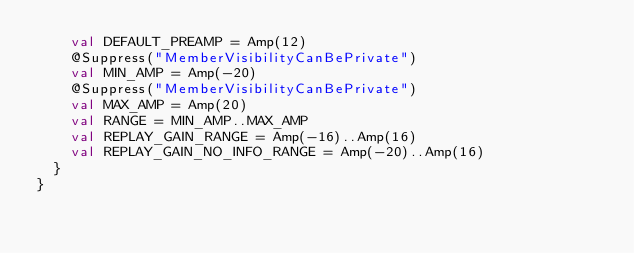<code> <loc_0><loc_0><loc_500><loc_500><_Kotlin_>    val DEFAULT_PREAMP = Amp(12)
    @Suppress("MemberVisibilityCanBePrivate")
    val MIN_AMP = Amp(-20)
    @Suppress("MemberVisibilityCanBePrivate")
    val MAX_AMP = Amp(20)
    val RANGE = MIN_AMP..MAX_AMP
    val REPLAY_GAIN_RANGE = Amp(-16)..Amp(16)
    val REPLAY_GAIN_NO_INFO_RANGE = Amp(-20)..Amp(16)
  }
}
</code> 